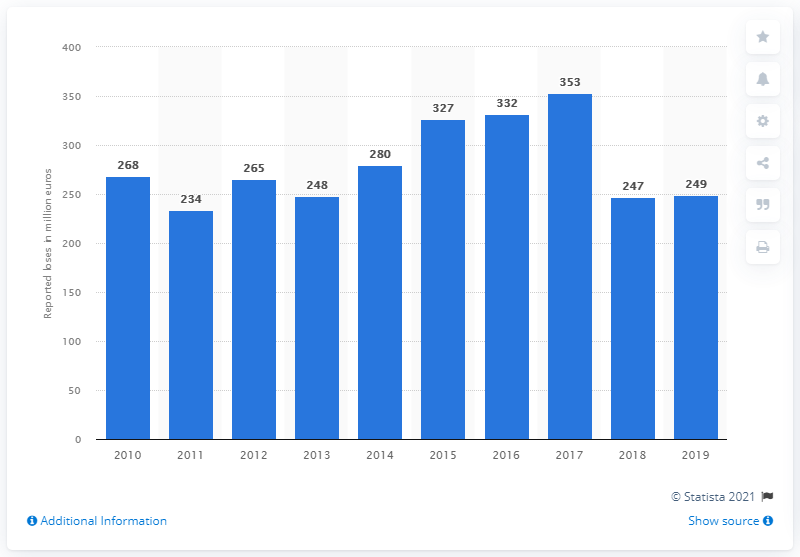Draw attention to some important aspects in this diagram. The reported losses in 2019 were 249. 